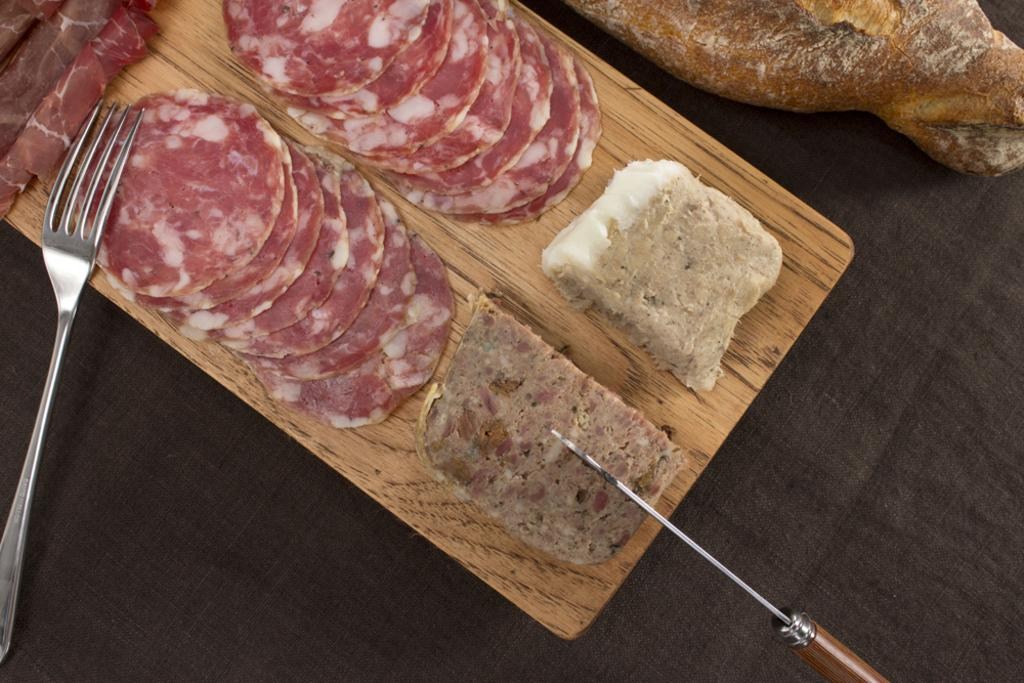What utensils are visible in the image? There is a fork and a knife in the image. What is the food placed on in the image? The food is placed on a wooden plank in the image. What type of cushion is placed under the wooden plank in the image? There is no cushion present in the image. 